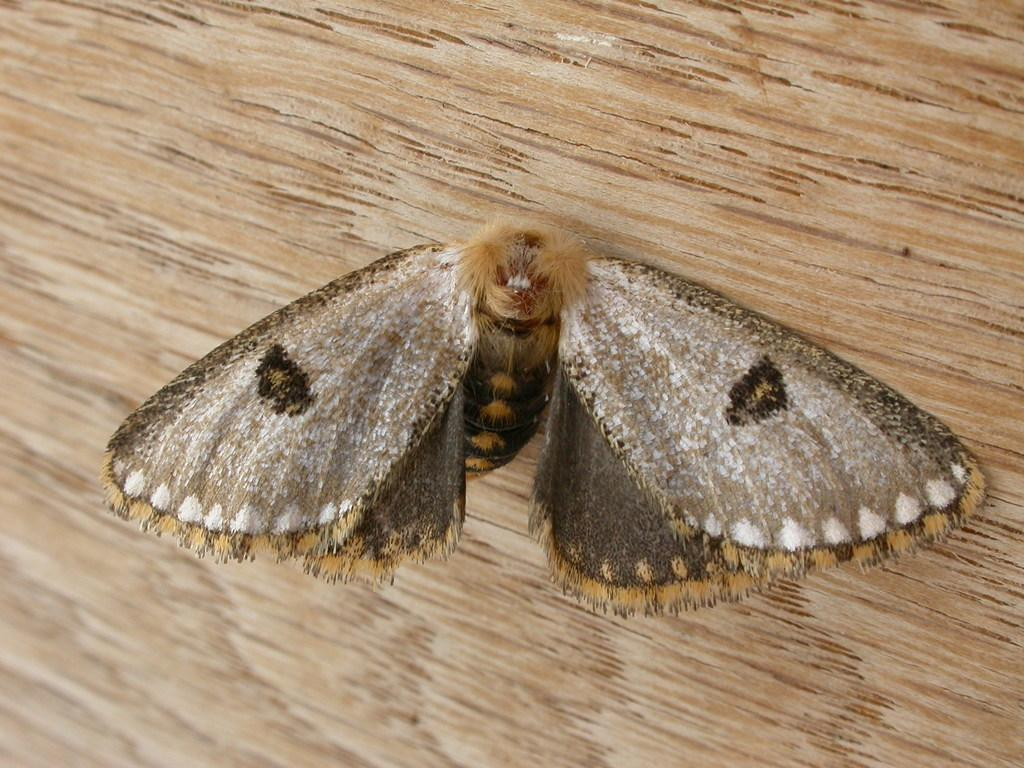What is the main subject of the image? There is a butterfly in the image. What type of surface is the butterfly on? The butterfly is on a wooden surface. What type of record is the butterfly holding in the image? There is no record present in the image, as the butterfly is not holding anything. 